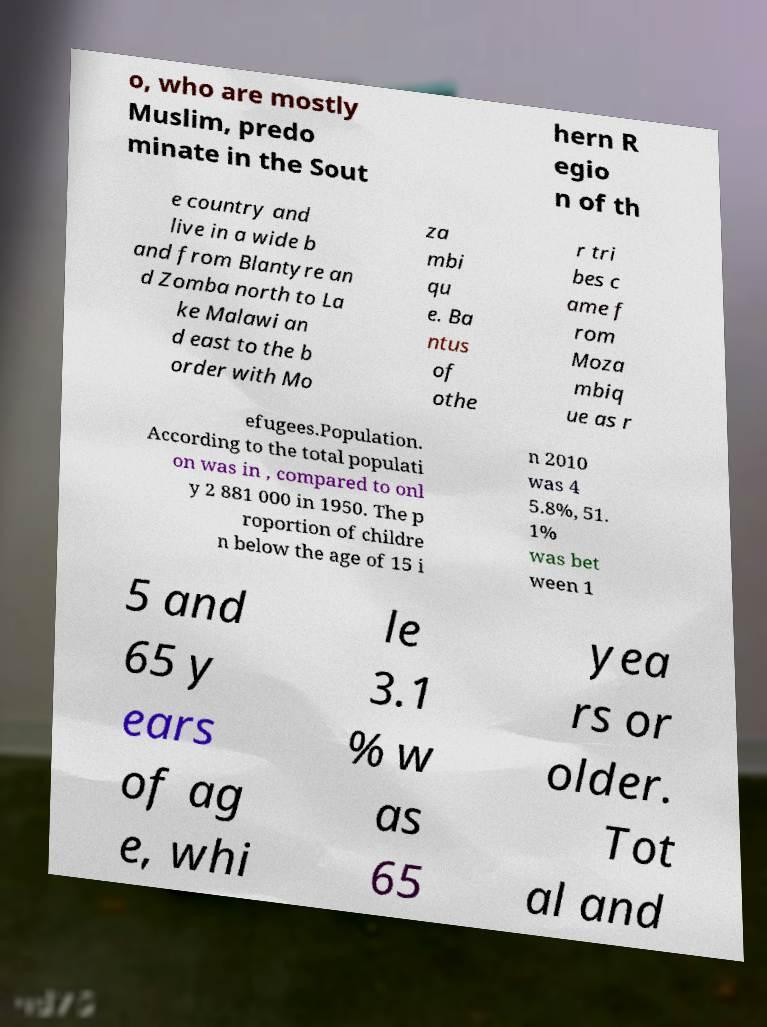There's text embedded in this image that I need extracted. Can you transcribe it verbatim? o, who are mostly Muslim, predo minate in the Sout hern R egio n of th e country and live in a wide b and from Blantyre an d Zomba north to La ke Malawi an d east to the b order with Mo za mbi qu e. Ba ntus of othe r tri bes c ame f rom Moza mbiq ue as r efugees.Population. According to the total populati on was in , compared to onl y 2 881 000 in 1950. The p roportion of childre n below the age of 15 i n 2010 was 4 5.8%, 51. 1% was bet ween 1 5 and 65 y ears of ag e, whi le 3.1 % w as 65 yea rs or older. Tot al and 